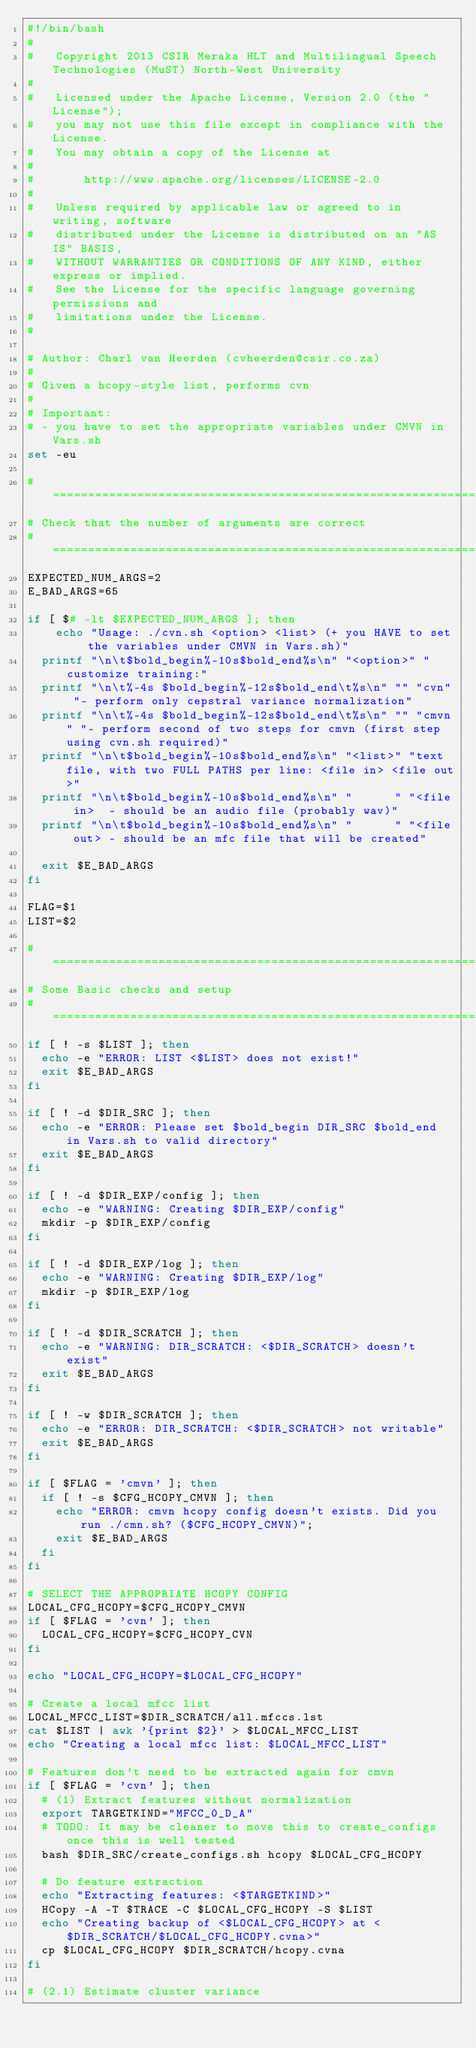<code> <loc_0><loc_0><loc_500><loc_500><_Bash_>#!/bin/bash
#
#   Copyright 2013 CSIR Meraka HLT and Multilingual Speech Technologies (MuST) North-West University
#
#   Licensed under the Apache License, Version 2.0 (the "License");
#   you may not use this file except in compliance with the License.
#   You may obtain a copy of the License at
#
#       http://www.apache.org/licenses/LICENSE-2.0
#
#   Unless required by applicable law or agreed to in writing, software
#   distributed under the License is distributed on an "AS IS" BASIS,
#   WITHOUT WARRANTIES OR CONDITIONS OF ANY KIND, either express or implied.
#   See the License for the specific language governing permissions and
#   limitations under the License.
#

# Author: Charl van Heerden (cvheerden@csir.co.za)
#
# Given a hcopy-style list, performs cvn
# 
# Important:
# - you have to set the appropriate variables under CMVN in Vars.sh
set -eu

#============================================================
# Check that the number of arguments are correct
#============================================================
EXPECTED_NUM_ARGS=2
E_BAD_ARGS=65

if [ $# -lt $EXPECTED_NUM_ARGS ]; then
	echo "Usage: ./cvn.sh <option> <list> (+ you HAVE to set the variables under CMVN in Vars.sh)"
  printf "\n\t$bold_begin%-10s$bold_end%s\n" "<option>" "customize training:"
  printf "\n\t%-4s $bold_begin%-12s$bold_end\t%s\n" "" "cvn" "- perform only cepstral variance normalization"
  printf "\n\t%-4s $bold_begin%-12s$bold_end\t%s\n" "" "cmvn" "- perform second of two steps for cmvn (first step using cvn.sh required)"
  printf "\n\t$bold_begin%-10s$bold_end%s\n" "<list>" "text file, with two FULL PATHS per line: <file in> <file out>"
  printf "\n\t$bold_begin%-10s$bold_end%s\n" "      " "<file in>  - should be an audio file (probably wav)"
  printf "\n\t$bold_begin%-10s$bold_end%s\n" "      " "<file out> - should be an mfc file that will be created"

  exit $E_BAD_ARGS
fi

FLAG=$1
LIST=$2

#============================================================
# Some Basic checks and setup
#============================================================
if [ ! -s $LIST ]; then
  echo -e "ERROR: LIST <$LIST> does not exist!"
  exit $E_BAD_ARGS
fi

if [ ! -d $DIR_SRC ]; then
  echo -e "ERROR: Please set $bold_begin DIR_SRC $bold_end in Vars.sh to valid directory"
  exit $E_BAD_ARGS
fi

if [ ! -d $DIR_EXP/config ]; then
  echo -e "WARNING: Creating $DIR_EXP/config"
  mkdir -p $DIR_EXP/config
fi

if [ ! -d $DIR_EXP/log ]; then
  echo -e "WARNING: Creating $DIR_EXP/log"
  mkdir -p $DIR_EXP/log
fi

if [ ! -d $DIR_SCRATCH ]; then
  echo -e "WARNING: DIR_SCRATCH: <$DIR_SCRATCH> doesn't exist"
  exit $E_BAD_ARGS
fi

if [ ! -w $DIR_SCRATCH ]; then
  echo -e "ERROR: DIR_SCRATCH: <$DIR_SCRATCH> not writable"
  exit $E_BAD_ARGS
fi

if [ $FLAG = 'cmvn' ]; then
  if [ ! -s $CFG_HCOPY_CMVN ]; then
    echo "ERROR: cmvn hcopy config doesn't exists. Did you run ./cmn.sh? ($CFG_HCOPY_CMVN)";
    exit $E_BAD_ARGS
  fi
fi

# SELECT THE APPROPRIATE HCOPY CONFIG
LOCAL_CFG_HCOPY=$CFG_HCOPY_CMVN
if [ $FLAG = 'cvn' ]; then
  LOCAL_CFG_HCOPY=$CFG_HCOPY_CVN
fi

echo "LOCAL_CFG_HCOPY=$LOCAL_CFG_HCOPY"

# Create a local mfcc list
LOCAL_MFCC_LIST=$DIR_SCRATCH/all.mfccs.lst
cat $LIST | awk '{print $2}' > $LOCAL_MFCC_LIST
echo "Creating a local mfcc list: $LOCAL_MFCC_LIST"

# Features don't need to be extracted again for cmvn
if [ $FLAG = 'cvn' ]; then
  # (1) Extract features without normalization
  export TARGETKIND="MFCC_0_D_A"
  # TODO: It may be cleaner to move this to create_configs once this is well tested
  bash $DIR_SRC/create_configs.sh hcopy $LOCAL_CFG_HCOPY

  # Do feature extraction
  echo "Extracting features: <$TARGETKIND>"
  HCopy -A -T $TRACE -C $LOCAL_CFG_HCOPY -S $LIST
  echo "Creating backup of <$LOCAL_CFG_HCOPY> at <$DIR_SCRATCH/$LOCAL_CFG_HCOPY.cvna>"
  cp $LOCAL_CFG_HCOPY $DIR_SCRATCH/hcopy.cvna
fi

# (2.1) Estimate cluster variance</code> 